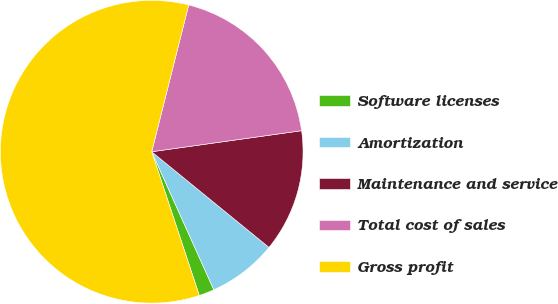Convert chart. <chart><loc_0><loc_0><loc_500><loc_500><pie_chart><fcel>Software licenses<fcel>Amortization<fcel>Maintenance and service<fcel>Total cost of sales<fcel>Gross profit<nl><fcel>1.64%<fcel>7.38%<fcel>13.11%<fcel>18.85%<fcel>59.02%<nl></chart> 